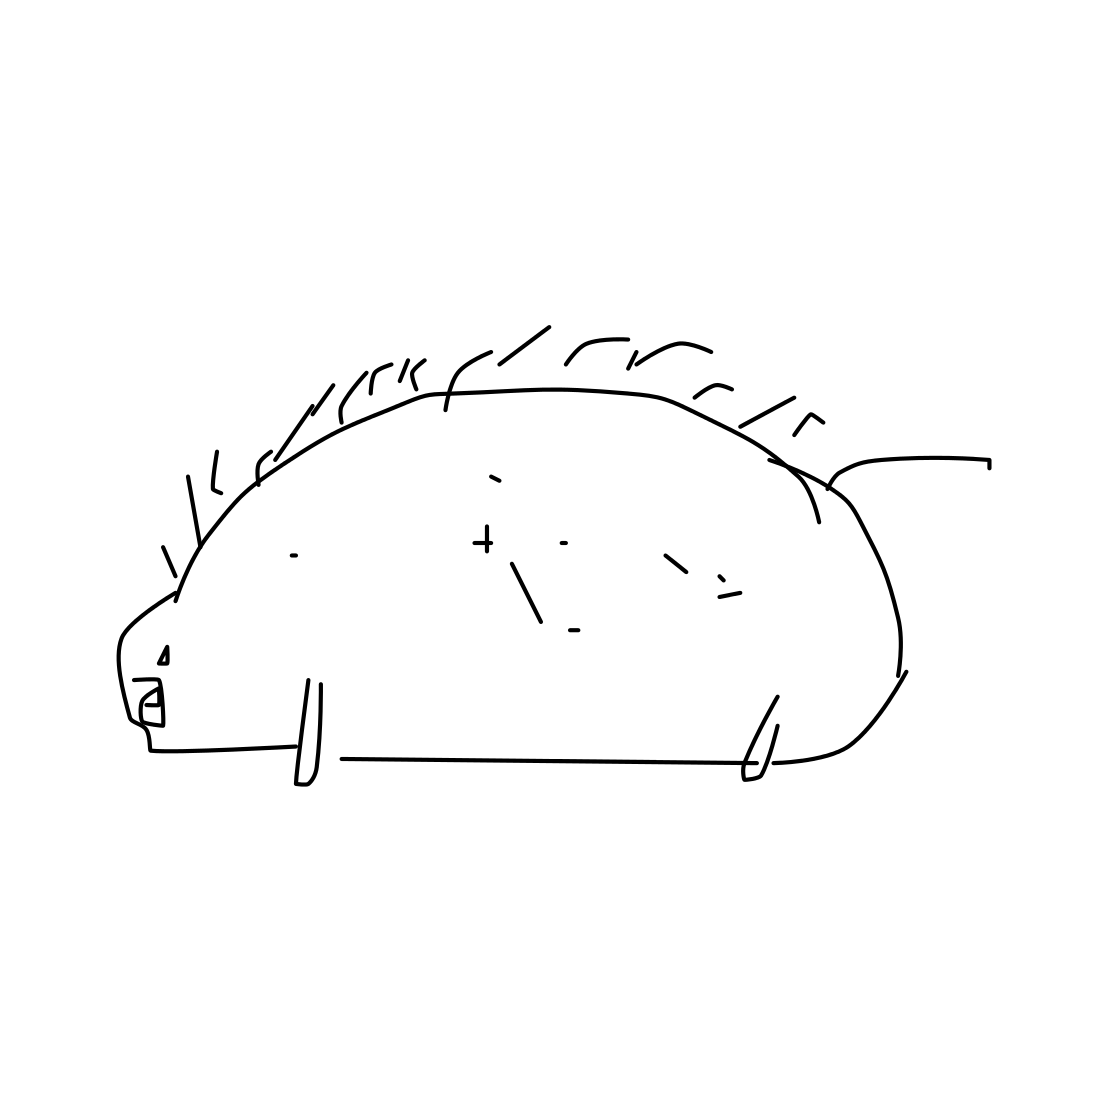How might this drawing of a hedgehog be used in a children's book? This style of drawing, with its charming simplicity, would be perfect for a children's book aiming to introduce young readers to basic shapes and elements of animals. Its clear, cartoonish depiction could help engage children and stimulate their imaginations. Absolutely! Its minimalistic charm and nostalgic feel could also attract adult audiences, particularly those appreciating minimalist art or looking for simplistic yet evocative designs for decorative purposes or creative projects. 